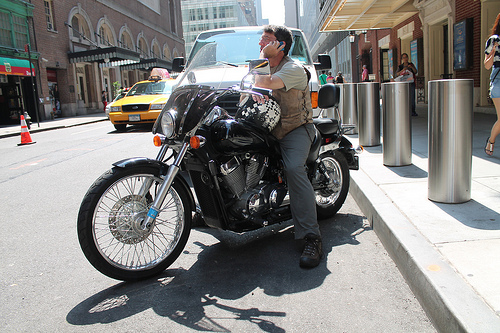What is the weather like in the image? The weather appears to be clear and sunny, as indicated by the shadows on the ground and the bright lighting conditions. 